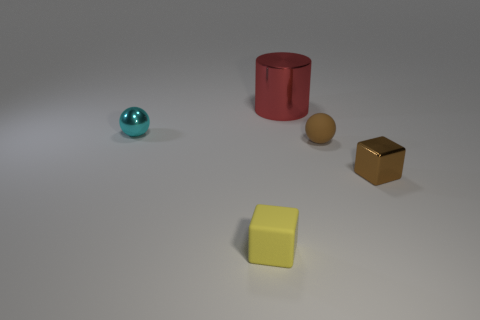Add 4 tiny shiny objects. How many objects exist? 9 Subtract all blocks. How many objects are left? 3 Subtract all tiny red rubber blocks. Subtract all cyan balls. How many objects are left? 4 Add 1 small brown matte balls. How many small brown matte balls are left? 2 Add 4 large red objects. How many large red objects exist? 5 Subtract 0 brown cylinders. How many objects are left? 5 